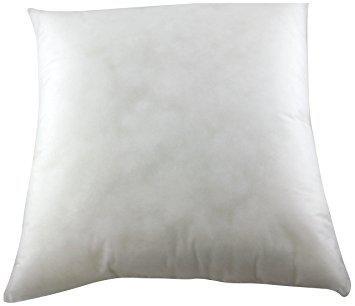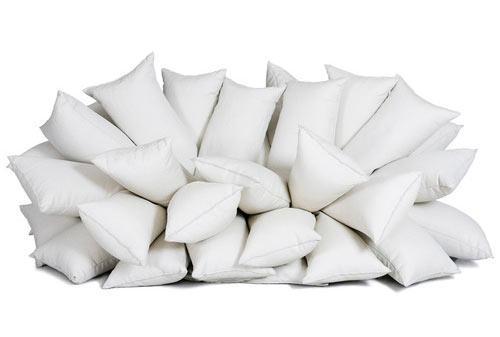The first image is the image on the left, the second image is the image on the right. For the images displayed, is the sentence "There is a single uncovered pillow in the left image." factually correct? Answer yes or no. Yes. The first image is the image on the left, the second image is the image on the right. Evaluate the accuracy of this statement regarding the images: "An image includes a pile of at least 10 white pillows.". Is it true? Answer yes or no. Yes. 